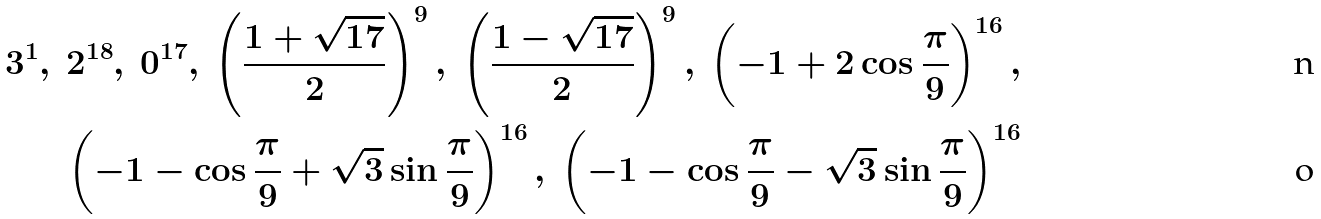Convert formula to latex. <formula><loc_0><loc_0><loc_500><loc_500>3 ^ { 1 } , \ 2 ^ { 1 8 } , \ 0 ^ { 1 7 } , \ \left ( \frac { 1 + \sqrt { 1 7 } } { 2 } \right ) ^ { 9 } , \ \left ( \frac { 1 - \sqrt { 1 7 } } { 2 } \right ) ^ { 9 } , \ \left ( - 1 + 2 \cos \frac { \pi } { 9 } \right ) ^ { 1 6 } , \\ \left ( - 1 - \cos \frac { \pi } { 9 } + \sqrt { 3 } \sin \frac { \pi } { 9 } \right ) ^ { 1 6 } , \ \left ( - 1 - \cos \frac { \pi } { 9 } - \sqrt { 3 } \sin \frac { \pi } { 9 } \right ) ^ { 1 6 }</formula> 